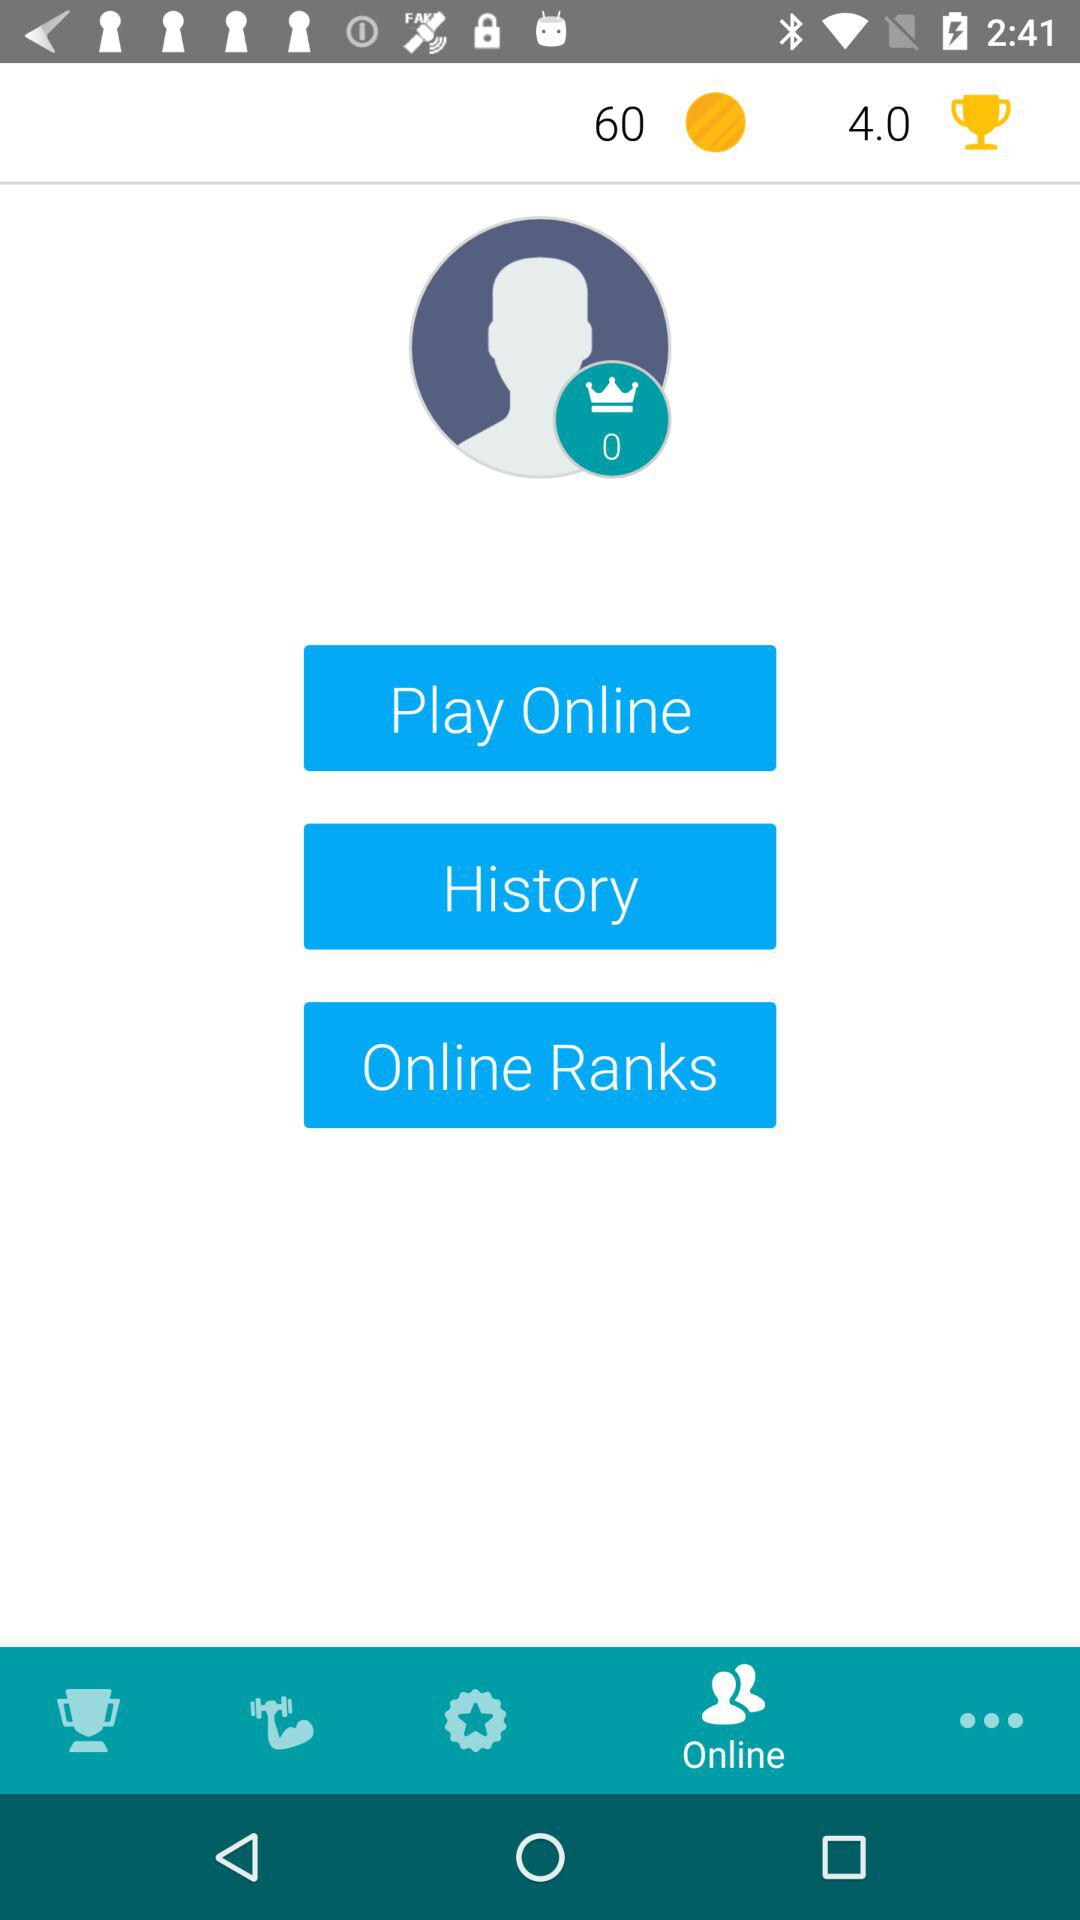What is the number of coins left? The number of coins left is 60. 